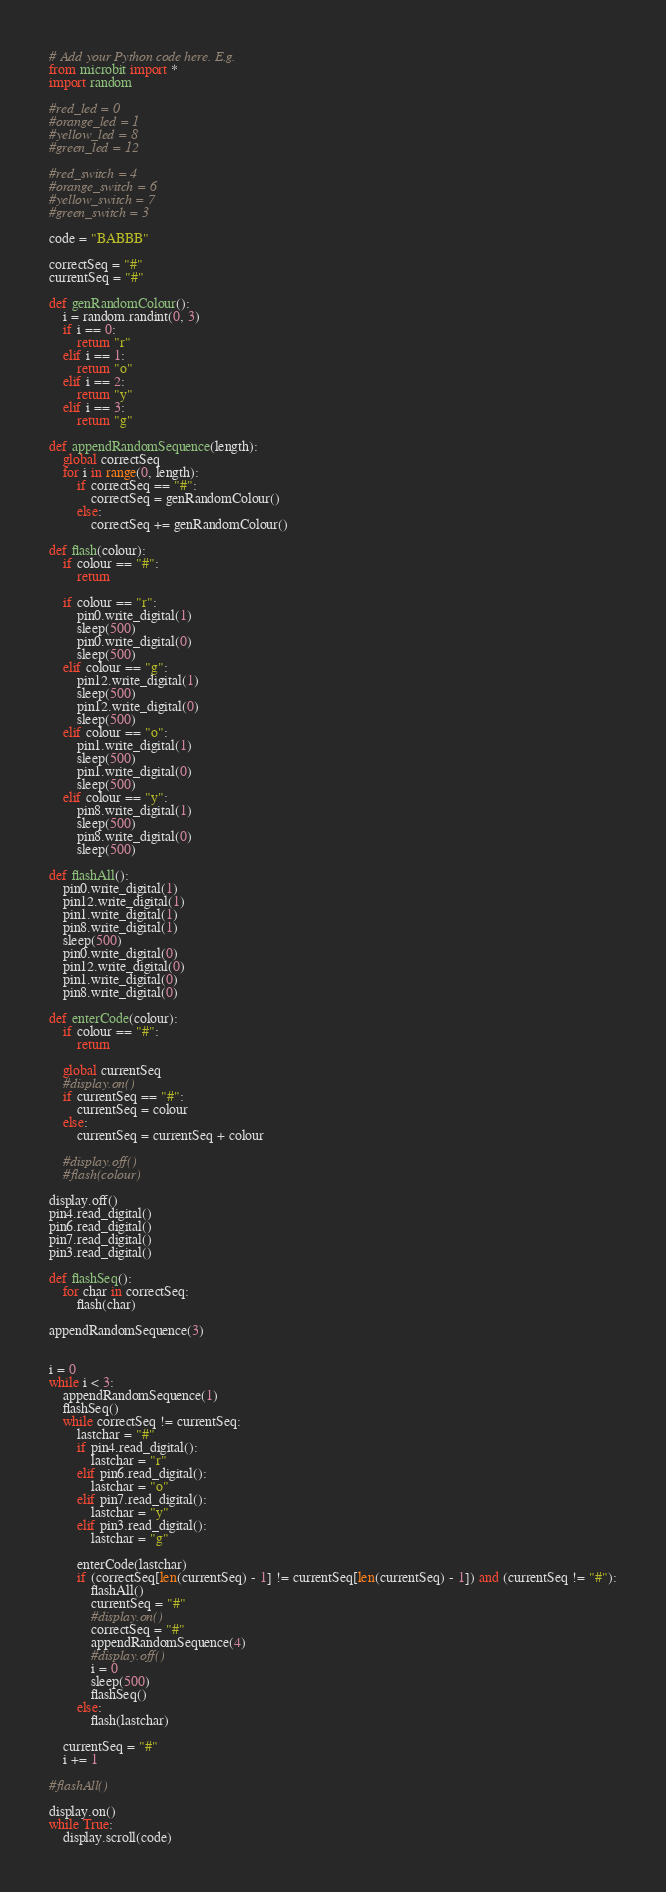<code> <loc_0><loc_0><loc_500><loc_500><_Python_># Add your Python code here. E.g.
from microbit import *
import random

#red_led = 0
#orange_led = 1
#yellow_led = 8
#green_led = 12

#red_switch = 4
#orange_switch = 6
#yellow_switch = 7
#green_switch = 3

code = "BABBB"

correctSeq = "#"
currentSeq = "#"

def genRandomColour():
    i = random.randint(0, 3)
    if i == 0:
        return "r"
    elif i == 1:
        return "o"
    elif i == 2:
        return "y"
    elif i == 3:
        return "g"

def appendRandomSequence(length):
    global correctSeq
    for i in range(0, length):
        if correctSeq == "#":
            correctSeq = genRandomColour()
        else:
            correctSeq += genRandomColour()

def flash(colour):
    if colour == "#":
        return

    if colour == "r":
        pin0.write_digital(1)
        sleep(500)
        pin0.write_digital(0)
        sleep(500)
    elif colour == "g":
        pin12.write_digital(1)
        sleep(500)
        pin12.write_digital(0)
        sleep(500)
    elif colour == "o":
        pin1.write_digital(1)
        sleep(500)
        pin1.write_digital(0)
        sleep(500)
    elif colour == "y":
        pin8.write_digital(1)
        sleep(500)
        pin8.write_digital(0)
        sleep(500)

def flashAll():
    pin0.write_digital(1)
    pin12.write_digital(1)
    pin1.write_digital(1)
    pin8.write_digital(1)
    sleep(500)
    pin0.write_digital(0)
    pin12.write_digital(0)
    pin1.write_digital(0)
    pin8.write_digital(0)

def enterCode(colour):
    if colour == "#":
        return
    
    global currentSeq
    #display.on()
    if currentSeq == "#":
        currentSeq = colour
    else:
        currentSeq = currentSeq + colour
    
    #display.off()
    #flash(colour)

display.off()
pin4.read_digital()
pin6.read_digital()
pin7.read_digital()
pin3.read_digital()

def flashSeq():
    for char in correctSeq:
        flash(char)

appendRandomSequence(3)


i = 0
while i < 3:
    appendRandomSequence(1)
    flashSeq()
    while correctSeq != currentSeq:
        lastchar = "#"
        if pin4.read_digital():
            lastchar = "r"
        elif pin6.read_digital():
            lastchar = "o"
        elif pin7.read_digital():
            lastchar = "y"
        elif pin3.read_digital():
            lastchar = "g"
    
        enterCode(lastchar)
        if (correctSeq[len(currentSeq) - 1] != currentSeq[len(currentSeq) - 1]) and (currentSeq != "#"):
            flashAll()
            currentSeq = "#"
            #display.on()
            correctSeq = "#"
            appendRandomSequence(4)
            #display.off()
            i = 0
            sleep(500)
            flashSeq()
        else:
            flash(lastchar)
    
    currentSeq = "#"
    i += 1

#flashAll()

display.on()
while True:
    display.scroll(code)
</code> 